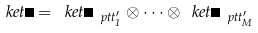<formula> <loc_0><loc_0><loc_500><loc_500>\ k e t { \Psi } = \ k e t { \Psi _ { \ p t t _ { 1 } ^ { \prime } } } \otimes \cdots \otimes \ k e t { \Psi _ { \ p t t _ { M } ^ { \prime } } }</formula> 